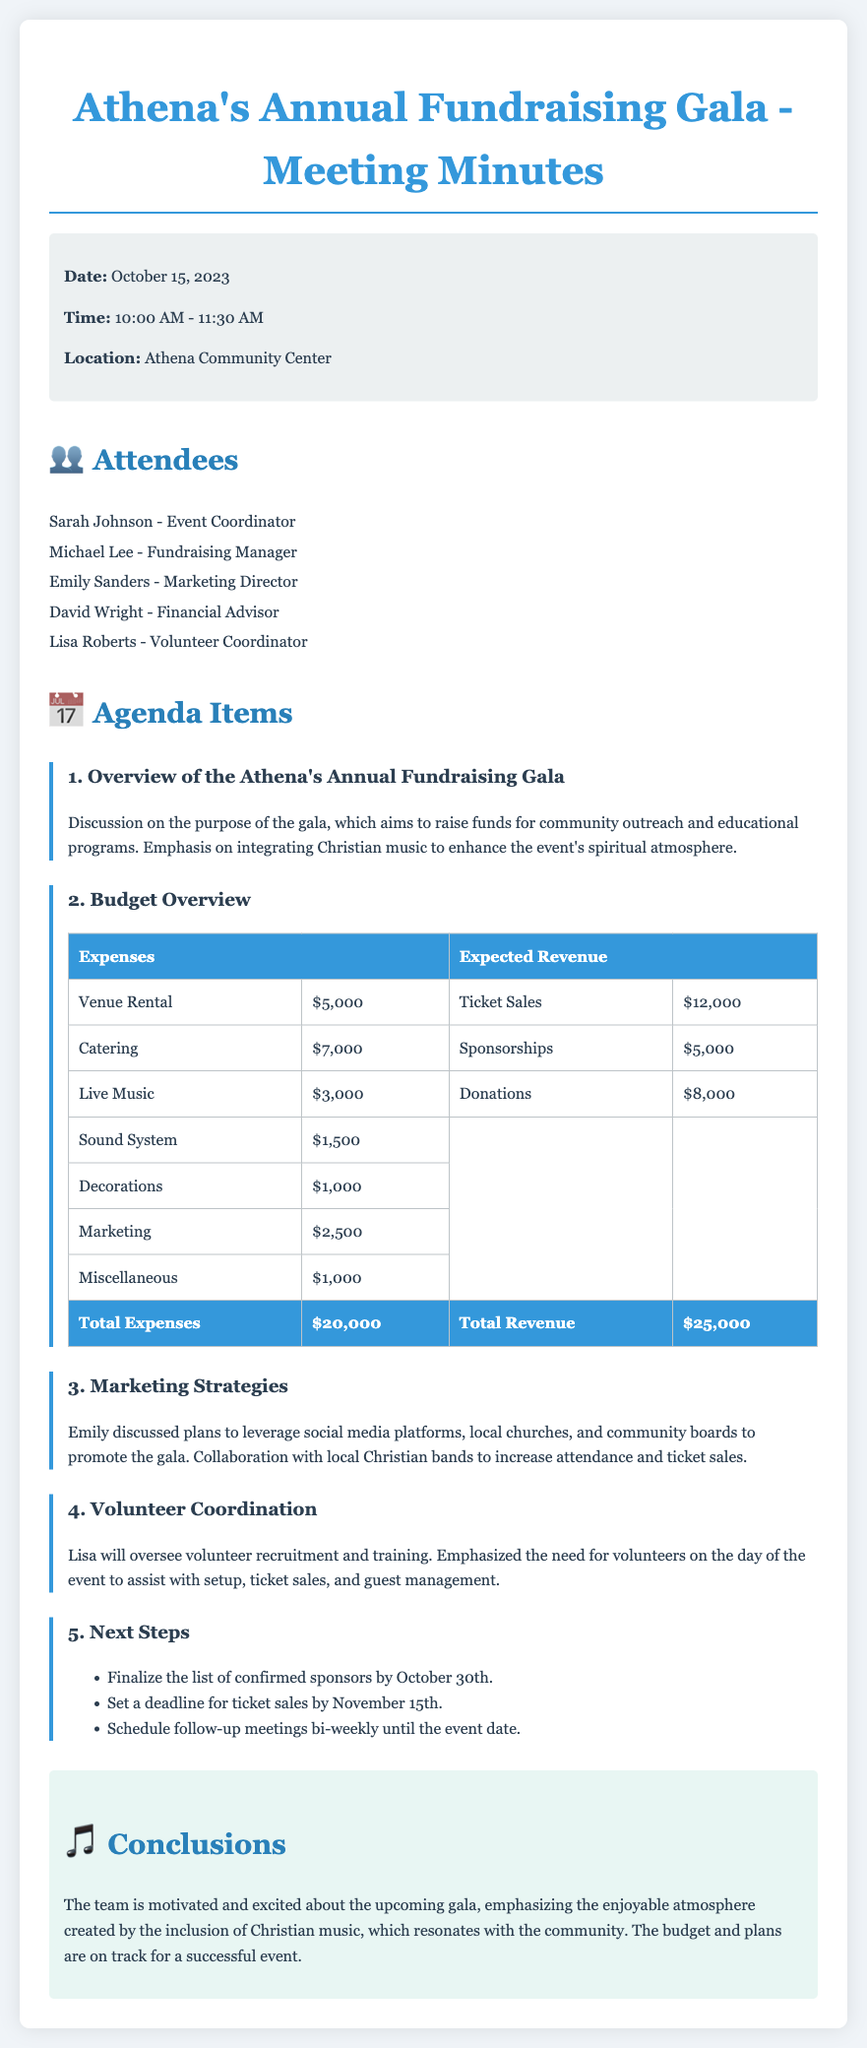What is the date of the meeting? The date is mentioned in the document as October 15, 2023.
Answer: October 15, 2023 Who is the Event Coordinator? The name of the Event Coordinator is listed as Sarah Johnson.
Answer: Sarah Johnson What is the total amount for expected revenue? The total expected revenue is calculated from the sums of ticket sales, sponsorships, and donations as shown in the budget overview, which totals $25,000.
Answer: $25,000 What is the expense for catering? The specific expense for catering is clearly listed in the expense table.
Answer: $7,000 How many attendees are listed? The document provides a list of attendees, allowing for a quick count of the names presented.
Answer: 5 What is the deadline for ticket sales? The deadline for ticket sales is mentioned in the Next Steps agenda item.
Answer: November 15th What is emphasized to enhance the event's atmosphere? The purpose of integrating a particular element into the gala is stated.
Answer: Christian music Who oversees volunteer recruitment? The person responsible for volunteer recruitment and training is mentioned in the agenda.
Answer: Lisa What is the total amount for expenses? The total expenses are summed up in the budget table part of the document.
Answer: $20,000 